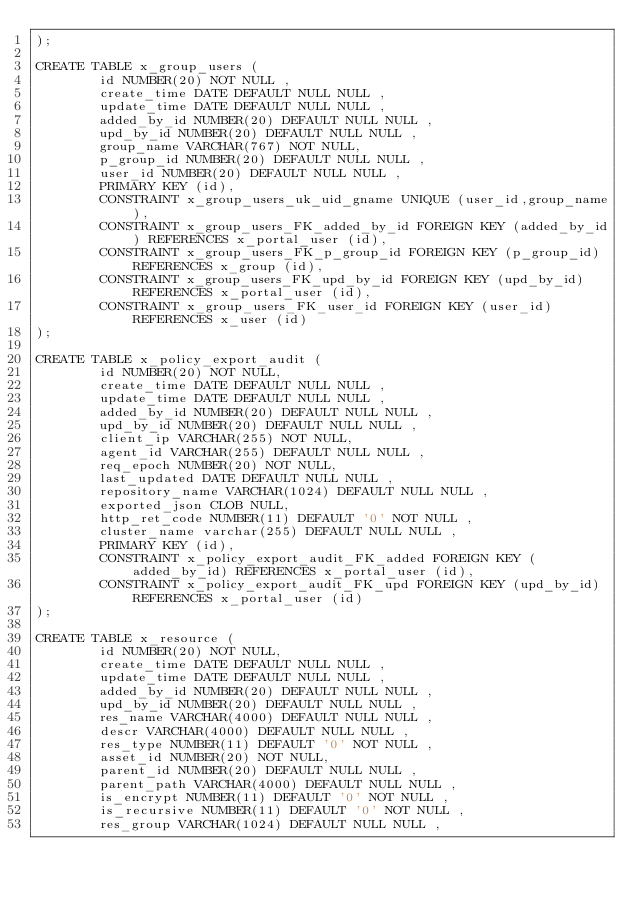<code> <loc_0><loc_0><loc_500><loc_500><_SQL_>);

CREATE TABLE x_group_users (
        id NUMBER(20) NOT NULL ,
        create_time DATE DEFAULT NULL NULL ,
        update_time DATE DEFAULT NULL NULL ,
        added_by_id NUMBER(20) DEFAULT NULL NULL ,
        upd_by_id NUMBER(20) DEFAULT NULL NULL ,
        group_name VARCHAR(767) NOT NULL,
        p_group_id NUMBER(20) DEFAULT NULL NULL ,
        user_id NUMBER(20) DEFAULT NULL NULL ,
        PRIMARY KEY (id),
        CONSTRAINT x_group_users_uk_uid_gname UNIQUE (user_id,group_name),
        CONSTRAINT x_group_users_FK_added_by_id FOREIGN KEY (added_by_id) REFERENCES x_portal_user (id),
        CONSTRAINT x_group_users_FK_p_group_id FOREIGN KEY (p_group_id) REFERENCES x_group (id),
        CONSTRAINT x_group_users_FK_upd_by_id FOREIGN KEY (upd_by_id) REFERENCES x_portal_user (id),
        CONSTRAINT x_group_users_FK_user_id FOREIGN KEY (user_id) REFERENCES x_user (id)
);

CREATE TABLE x_policy_export_audit (
        id NUMBER(20) NOT NULL,
        create_time DATE DEFAULT NULL NULL ,
        update_time DATE DEFAULT NULL NULL ,
        added_by_id NUMBER(20) DEFAULT NULL NULL ,
        upd_by_id NUMBER(20) DEFAULT NULL NULL ,
        client_ip VARCHAR(255) NOT NULL,
        agent_id VARCHAR(255) DEFAULT NULL NULL ,
        req_epoch NUMBER(20) NOT NULL,
        last_updated DATE DEFAULT NULL NULL ,
        repository_name VARCHAR(1024) DEFAULT NULL NULL ,
        exported_json CLOB NULL,
        http_ret_code NUMBER(11) DEFAULT '0' NOT NULL ,
        cluster_name varchar(255) DEFAULT NULL NULL ,
        PRIMARY KEY (id),
        CONSTRAINT x_policy_export_audit_FK_added FOREIGN KEY (added_by_id) REFERENCES x_portal_user (id),
        CONSTRAINT x_policy_export_audit_FK_upd FOREIGN KEY (upd_by_id) REFERENCES x_portal_user (id)
);

CREATE TABLE x_resource (
        id NUMBER(20) NOT NULL,
        create_time DATE DEFAULT NULL NULL ,
        update_time DATE DEFAULT NULL NULL ,
        added_by_id NUMBER(20) DEFAULT NULL NULL ,
        upd_by_id NUMBER(20) DEFAULT NULL NULL ,
        res_name VARCHAR(4000) DEFAULT NULL NULL ,
        descr VARCHAR(4000) DEFAULT NULL NULL ,
        res_type NUMBER(11) DEFAULT '0' NOT NULL ,
        asset_id NUMBER(20) NOT NULL,
        parent_id NUMBER(20) DEFAULT NULL NULL ,
        parent_path VARCHAR(4000) DEFAULT NULL NULL ,
        is_encrypt NUMBER(11) DEFAULT '0' NOT NULL ,
        is_recursive NUMBER(11) DEFAULT '0' NOT NULL ,
        res_group VARCHAR(1024) DEFAULT NULL NULL ,</code> 